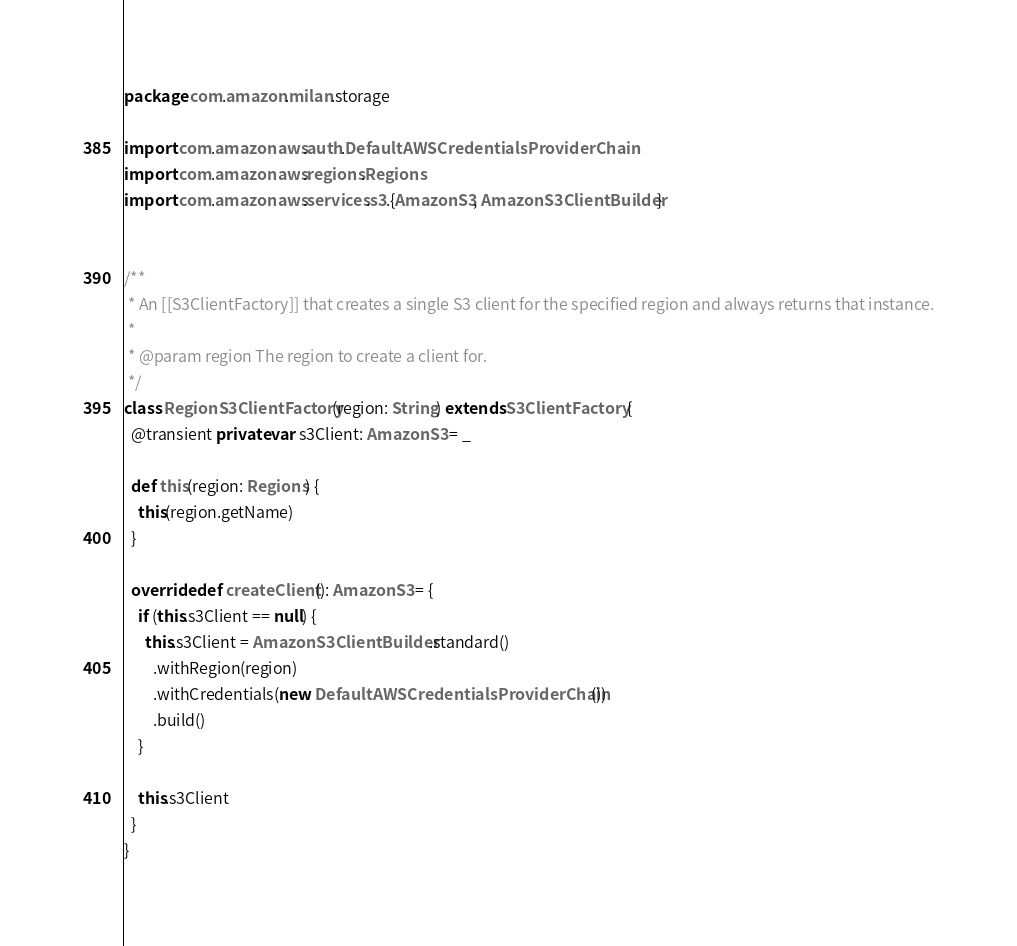Convert code to text. <code><loc_0><loc_0><loc_500><loc_500><_Scala_>package com.amazon.milan.storage

import com.amazonaws.auth.DefaultAWSCredentialsProviderChain
import com.amazonaws.regions.Regions
import com.amazonaws.services.s3.{AmazonS3, AmazonS3ClientBuilder}


/**
 * An [[S3ClientFactory]] that creates a single S3 client for the specified region and always returns that instance.
 *
 * @param region The region to create a client for.
 */
class RegionS3ClientFactory(region: String) extends S3ClientFactory {
  @transient private var s3Client: AmazonS3 = _

  def this(region: Regions) {
    this(region.getName)
  }

  override def createClient(): AmazonS3 = {
    if (this.s3Client == null) {
      this.s3Client = AmazonS3ClientBuilder.standard()
        .withRegion(region)
        .withCredentials(new DefaultAWSCredentialsProviderChain())
        .build()
    }

    this.s3Client
  }
}
</code> 